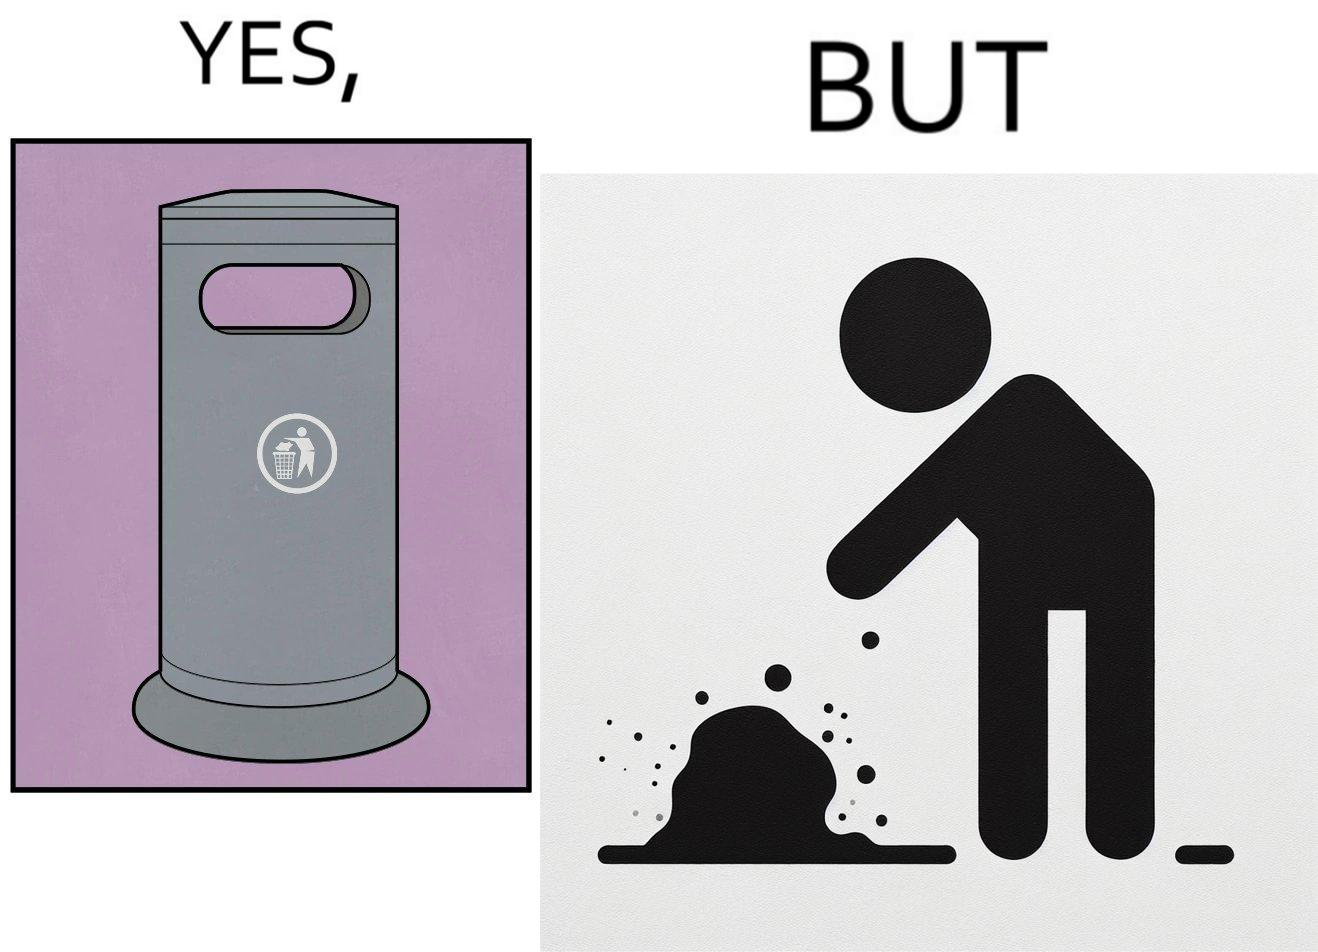What is shown in this image? The images are ironic because even though garbage bins are provided for humans to dispose waste, by habit humans still choose to make surroundings dirty by disposing garbage improperly 